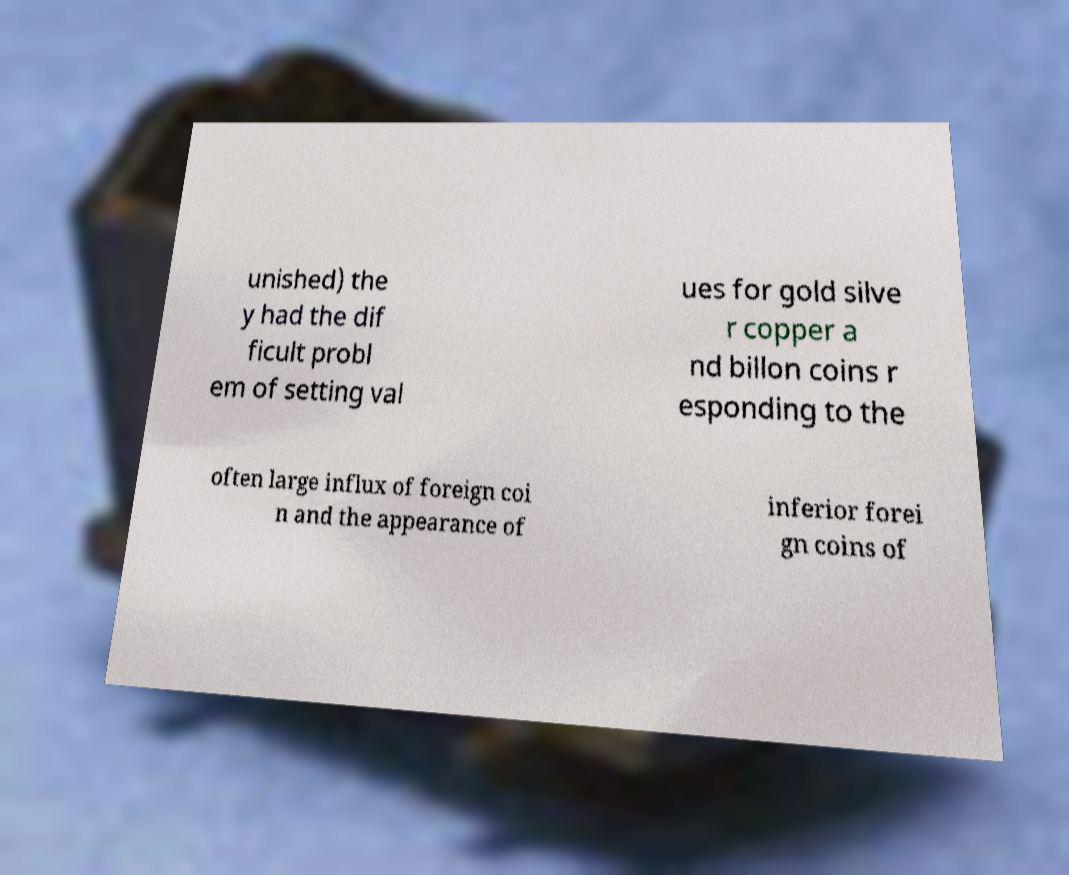I need the written content from this picture converted into text. Can you do that? unished) the y had the dif ficult probl em of setting val ues for gold silve r copper a nd billon coins r esponding to the often large influx of foreign coi n and the appearance of inferior forei gn coins of 